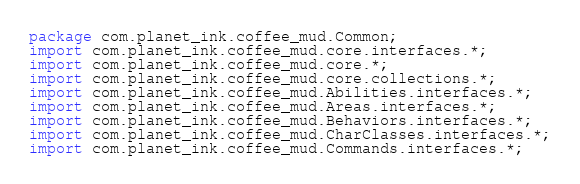<code> <loc_0><loc_0><loc_500><loc_500><_Java_>package com.planet_ink.coffee_mud.Common;
import com.planet_ink.coffee_mud.core.interfaces.*;
import com.planet_ink.coffee_mud.core.*;
import com.planet_ink.coffee_mud.core.collections.*;
import com.planet_ink.coffee_mud.Abilities.interfaces.*;
import com.planet_ink.coffee_mud.Areas.interfaces.*;
import com.planet_ink.coffee_mud.Behaviors.interfaces.*;
import com.planet_ink.coffee_mud.CharClasses.interfaces.*;
import com.planet_ink.coffee_mud.Commands.interfaces.*;</code> 